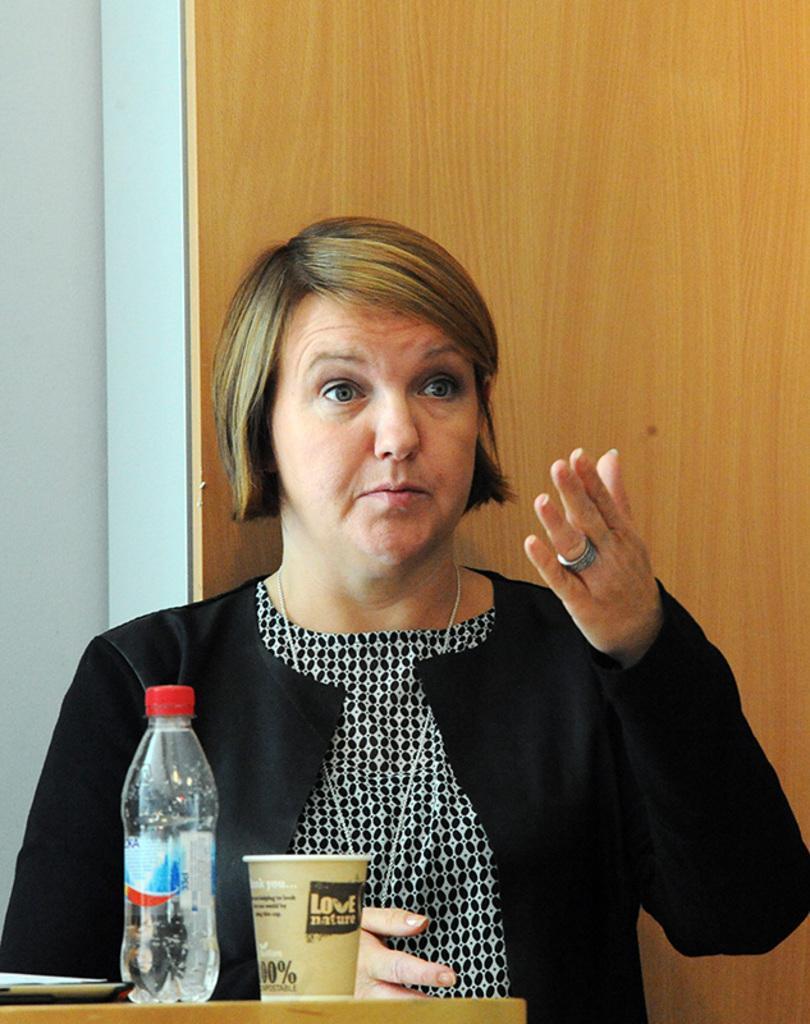Could you give a brief overview of what you see in this image? There is a woman pointing her hands and there is a table and on the table, there is one glass and one bottle. And on the background there is a wall. 